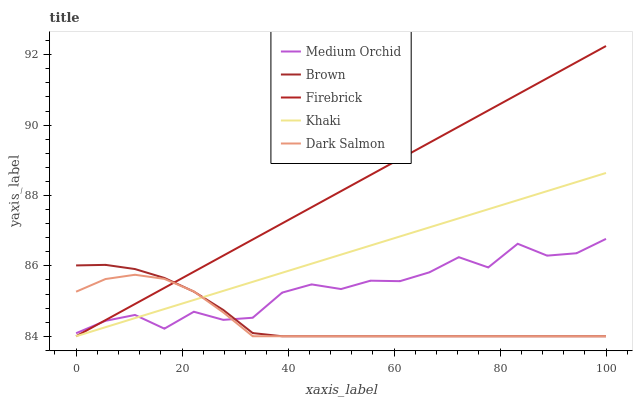Does Dark Salmon have the minimum area under the curve?
Answer yes or no. Yes. Does Firebrick have the maximum area under the curve?
Answer yes or no. Yes. Does Medium Orchid have the minimum area under the curve?
Answer yes or no. No. Does Medium Orchid have the maximum area under the curve?
Answer yes or no. No. Is Firebrick the smoothest?
Answer yes or no. Yes. Is Medium Orchid the roughest?
Answer yes or no. Yes. Is Medium Orchid the smoothest?
Answer yes or no. No. Is Firebrick the roughest?
Answer yes or no. No. Does Brown have the lowest value?
Answer yes or no. Yes. Does Medium Orchid have the lowest value?
Answer yes or no. No. Does Firebrick have the highest value?
Answer yes or no. Yes. Does Medium Orchid have the highest value?
Answer yes or no. No. Does Medium Orchid intersect Brown?
Answer yes or no. Yes. Is Medium Orchid less than Brown?
Answer yes or no. No. Is Medium Orchid greater than Brown?
Answer yes or no. No. 